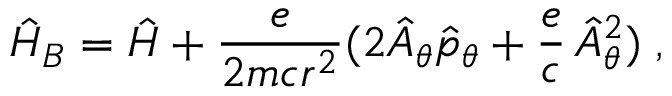<formula> <loc_0><loc_0><loc_500><loc_500>\hat { H } _ { B } = \hat { H } + \frac { e } { 2 m c r ^ { 2 } } ( 2 \hat { A } _ { \theta } \hat { p } _ { \theta } + \frac { e } { c } \, \hat { A } _ { \theta } ^ { 2 } ) \, ,</formula> 